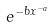Convert formula to latex. <formula><loc_0><loc_0><loc_500><loc_500>e ^ { - b x ^ { - a } }</formula> 